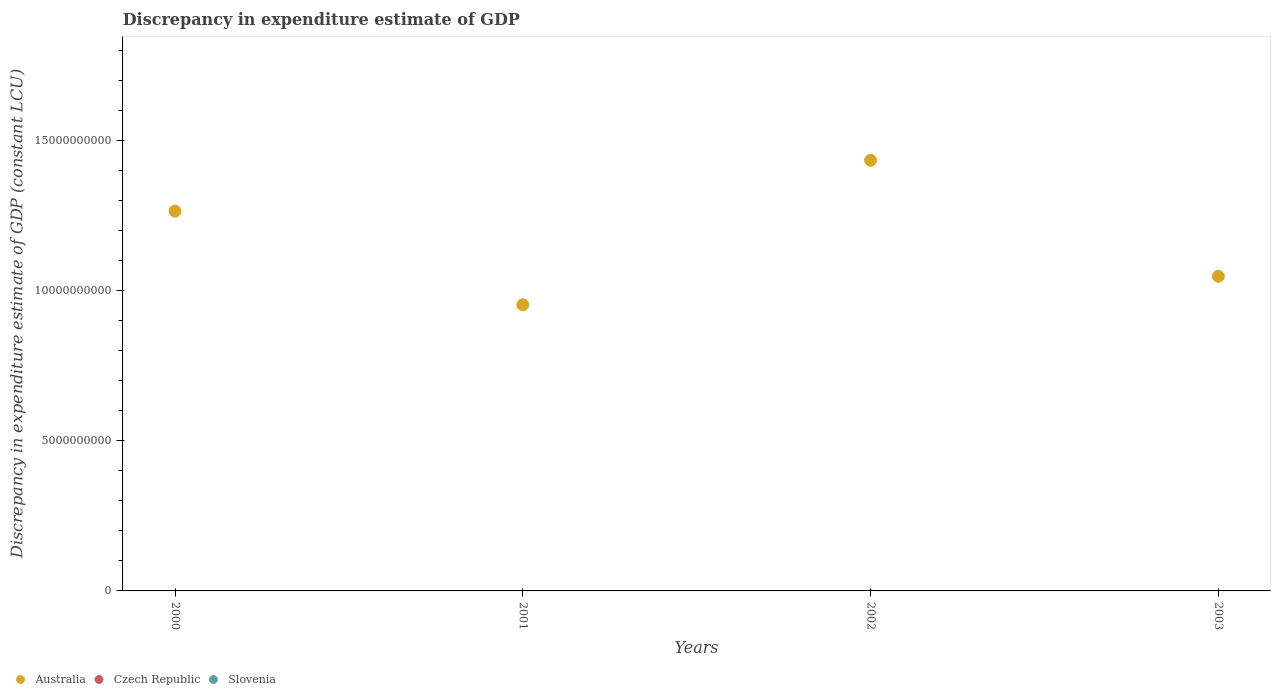How many different coloured dotlines are there?
Provide a short and direct response. 1. What is the discrepancy in expenditure estimate of GDP in Australia in 2003?
Give a very brief answer. 1.05e+1. Across all years, what is the maximum discrepancy in expenditure estimate of GDP in Australia?
Your answer should be very brief. 1.44e+1. What is the total discrepancy in expenditure estimate of GDP in Australia in the graph?
Ensure brevity in your answer.  4.70e+1. What is the difference between the discrepancy in expenditure estimate of GDP in Australia in 2002 and that in 2003?
Give a very brief answer. 3.87e+09. What is the difference between the discrepancy in expenditure estimate of GDP in Czech Republic in 2002 and the discrepancy in expenditure estimate of GDP in Slovenia in 2001?
Your answer should be compact. 0. What is the ratio of the discrepancy in expenditure estimate of GDP in Australia in 2001 to that in 2003?
Your answer should be very brief. 0.91. Is the discrepancy in expenditure estimate of GDP in Australia in 2000 less than that in 2001?
Provide a short and direct response. No. What is the difference between the highest and the second highest discrepancy in expenditure estimate of GDP in Australia?
Your answer should be compact. 1.69e+09. What is the difference between the highest and the lowest discrepancy in expenditure estimate of GDP in Australia?
Keep it short and to the point. 4.82e+09. In how many years, is the discrepancy in expenditure estimate of GDP in Australia greater than the average discrepancy in expenditure estimate of GDP in Australia taken over all years?
Offer a terse response. 2. Is the sum of the discrepancy in expenditure estimate of GDP in Australia in 2001 and 2003 greater than the maximum discrepancy in expenditure estimate of GDP in Czech Republic across all years?
Keep it short and to the point. Yes. Is it the case that in every year, the sum of the discrepancy in expenditure estimate of GDP in Slovenia and discrepancy in expenditure estimate of GDP in Czech Republic  is greater than the discrepancy in expenditure estimate of GDP in Australia?
Give a very brief answer. No. Is the discrepancy in expenditure estimate of GDP in Australia strictly less than the discrepancy in expenditure estimate of GDP in Czech Republic over the years?
Give a very brief answer. No. How many dotlines are there?
Your answer should be compact. 1. How many years are there in the graph?
Your answer should be very brief. 4. Does the graph contain any zero values?
Provide a succinct answer. Yes. Where does the legend appear in the graph?
Your answer should be compact. Bottom left. How many legend labels are there?
Keep it short and to the point. 3. What is the title of the graph?
Give a very brief answer. Discrepancy in expenditure estimate of GDP. What is the label or title of the Y-axis?
Make the answer very short. Discrepancy in expenditure estimate of GDP (constant LCU). What is the Discrepancy in expenditure estimate of GDP (constant LCU) of Australia in 2000?
Offer a terse response. 1.27e+1. What is the Discrepancy in expenditure estimate of GDP (constant LCU) of Czech Republic in 2000?
Keep it short and to the point. 0. What is the Discrepancy in expenditure estimate of GDP (constant LCU) of Australia in 2001?
Give a very brief answer. 9.54e+09. What is the Discrepancy in expenditure estimate of GDP (constant LCU) in Slovenia in 2001?
Your answer should be very brief. 0. What is the Discrepancy in expenditure estimate of GDP (constant LCU) of Australia in 2002?
Your response must be concise. 1.44e+1. What is the Discrepancy in expenditure estimate of GDP (constant LCU) of Czech Republic in 2002?
Your answer should be very brief. 0. What is the Discrepancy in expenditure estimate of GDP (constant LCU) of Australia in 2003?
Your answer should be very brief. 1.05e+1. Across all years, what is the maximum Discrepancy in expenditure estimate of GDP (constant LCU) of Australia?
Provide a short and direct response. 1.44e+1. Across all years, what is the minimum Discrepancy in expenditure estimate of GDP (constant LCU) in Australia?
Offer a very short reply. 9.54e+09. What is the total Discrepancy in expenditure estimate of GDP (constant LCU) of Australia in the graph?
Offer a terse response. 4.70e+1. What is the total Discrepancy in expenditure estimate of GDP (constant LCU) in Czech Republic in the graph?
Make the answer very short. 0. What is the difference between the Discrepancy in expenditure estimate of GDP (constant LCU) of Australia in 2000 and that in 2001?
Offer a very short reply. 3.12e+09. What is the difference between the Discrepancy in expenditure estimate of GDP (constant LCU) in Australia in 2000 and that in 2002?
Make the answer very short. -1.69e+09. What is the difference between the Discrepancy in expenditure estimate of GDP (constant LCU) in Australia in 2000 and that in 2003?
Make the answer very short. 2.17e+09. What is the difference between the Discrepancy in expenditure estimate of GDP (constant LCU) of Australia in 2001 and that in 2002?
Your answer should be compact. -4.82e+09. What is the difference between the Discrepancy in expenditure estimate of GDP (constant LCU) of Australia in 2001 and that in 2003?
Make the answer very short. -9.50e+08. What is the difference between the Discrepancy in expenditure estimate of GDP (constant LCU) of Australia in 2002 and that in 2003?
Make the answer very short. 3.87e+09. What is the average Discrepancy in expenditure estimate of GDP (constant LCU) in Australia per year?
Provide a short and direct response. 1.18e+1. What is the ratio of the Discrepancy in expenditure estimate of GDP (constant LCU) in Australia in 2000 to that in 2001?
Offer a terse response. 1.33. What is the ratio of the Discrepancy in expenditure estimate of GDP (constant LCU) of Australia in 2000 to that in 2002?
Give a very brief answer. 0.88. What is the ratio of the Discrepancy in expenditure estimate of GDP (constant LCU) in Australia in 2000 to that in 2003?
Offer a terse response. 1.21. What is the ratio of the Discrepancy in expenditure estimate of GDP (constant LCU) in Australia in 2001 to that in 2002?
Offer a very short reply. 0.66. What is the ratio of the Discrepancy in expenditure estimate of GDP (constant LCU) of Australia in 2001 to that in 2003?
Your response must be concise. 0.91. What is the ratio of the Discrepancy in expenditure estimate of GDP (constant LCU) of Australia in 2002 to that in 2003?
Provide a short and direct response. 1.37. What is the difference between the highest and the second highest Discrepancy in expenditure estimate of GDP (constant LCU) in Australia?
Your answer should be very brief. 1.69e+09. What is the difference between the highest and the lowest Discrepancy in expenditure estimate of GDP (constant LCU) of Australia?
Your response must be concise. 4.82e+09. 